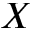<formula> <loc_0><loc_0><loc_500><loc_500>X</formula> 